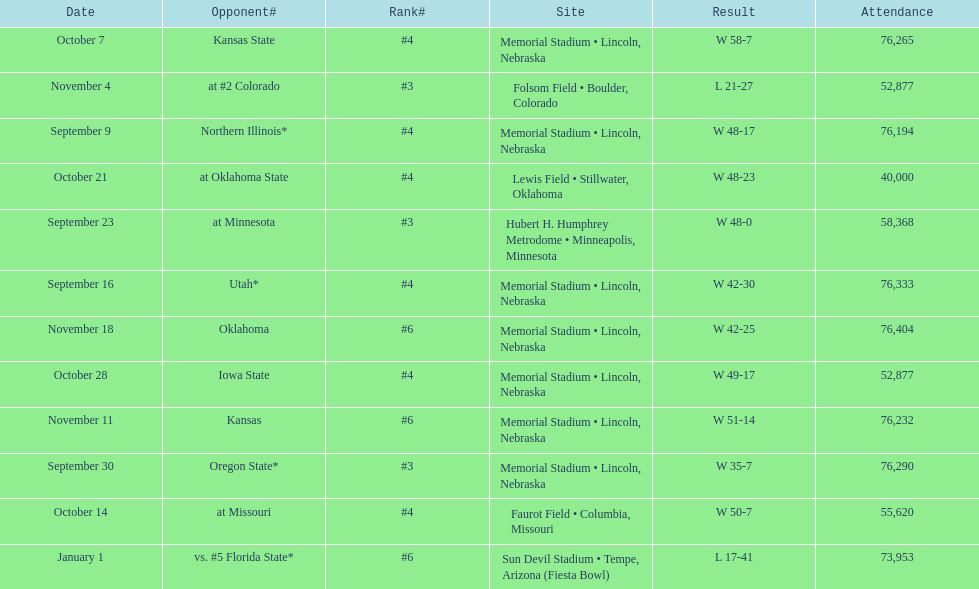How many games was their ranking not lower than #5? 9. 